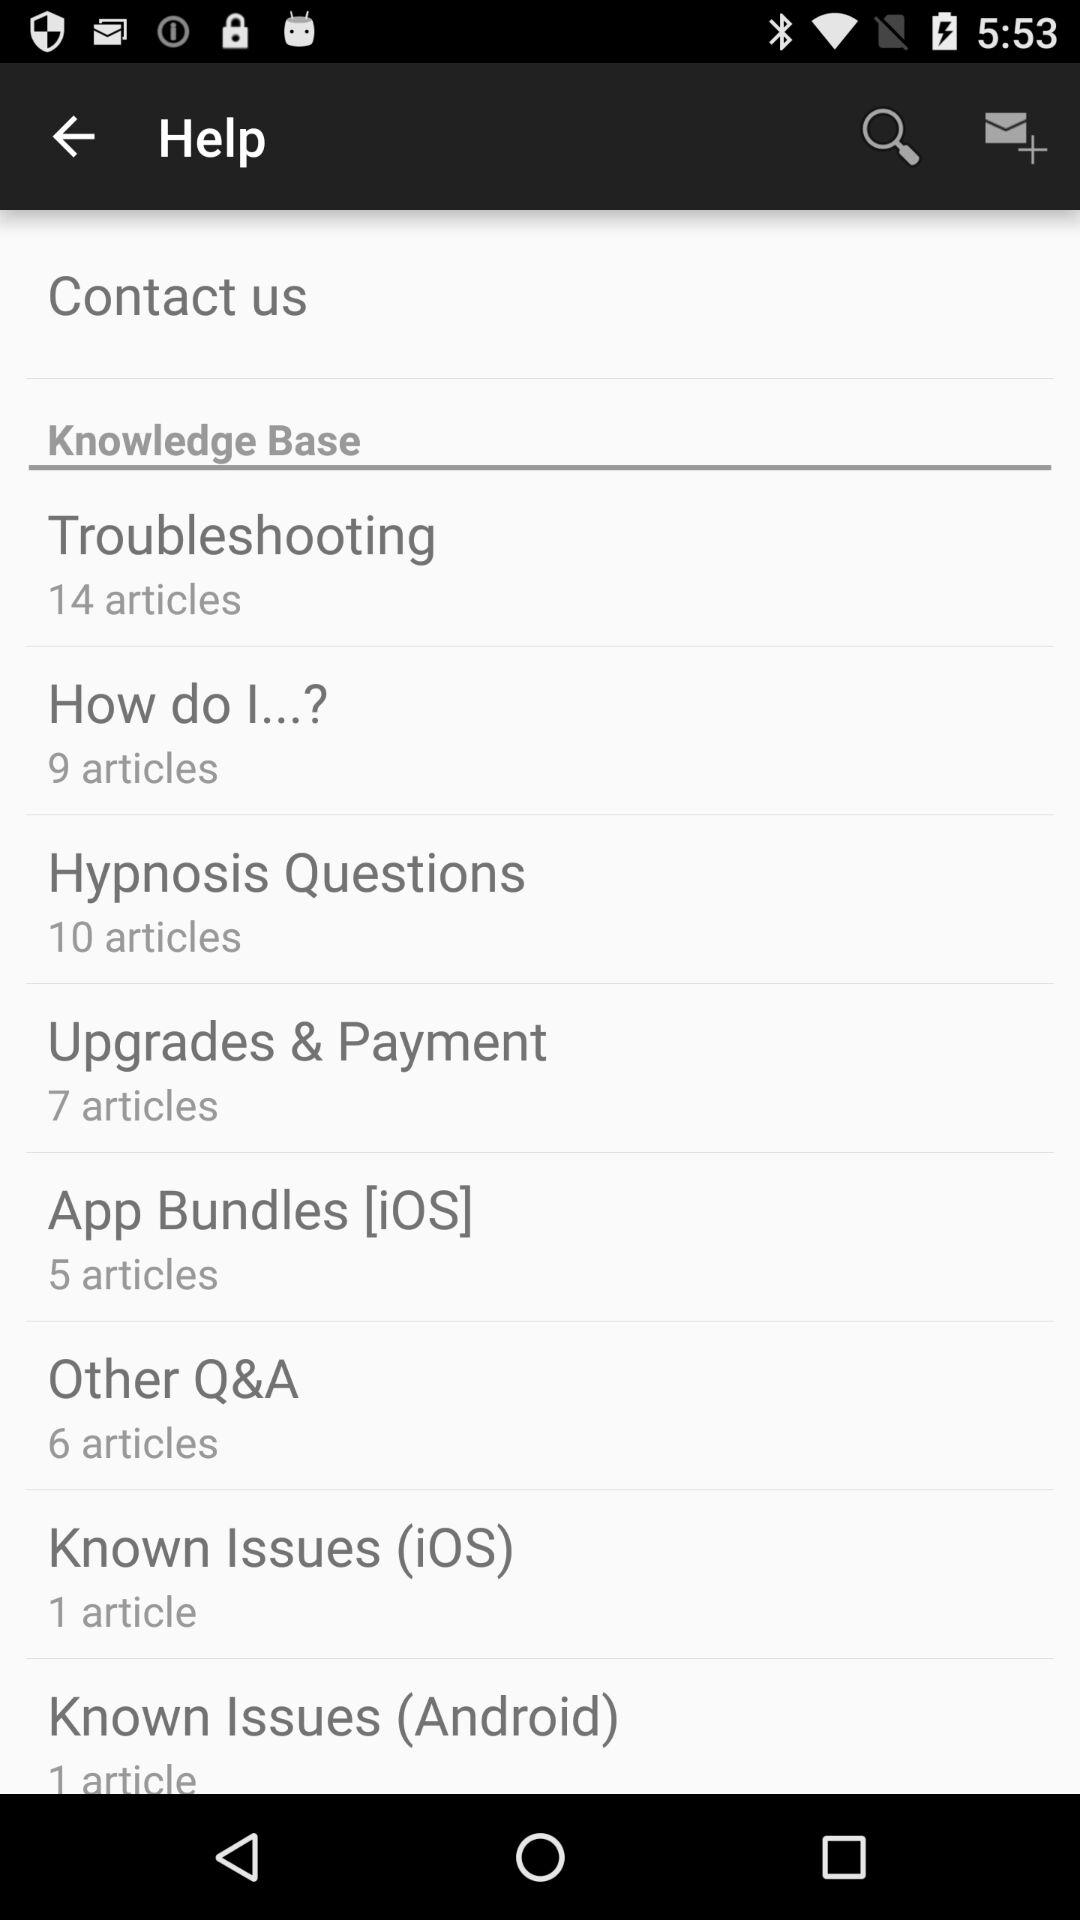How many articles are there about upgrades and payment?
Answer the question using a single word or phrase. 7 